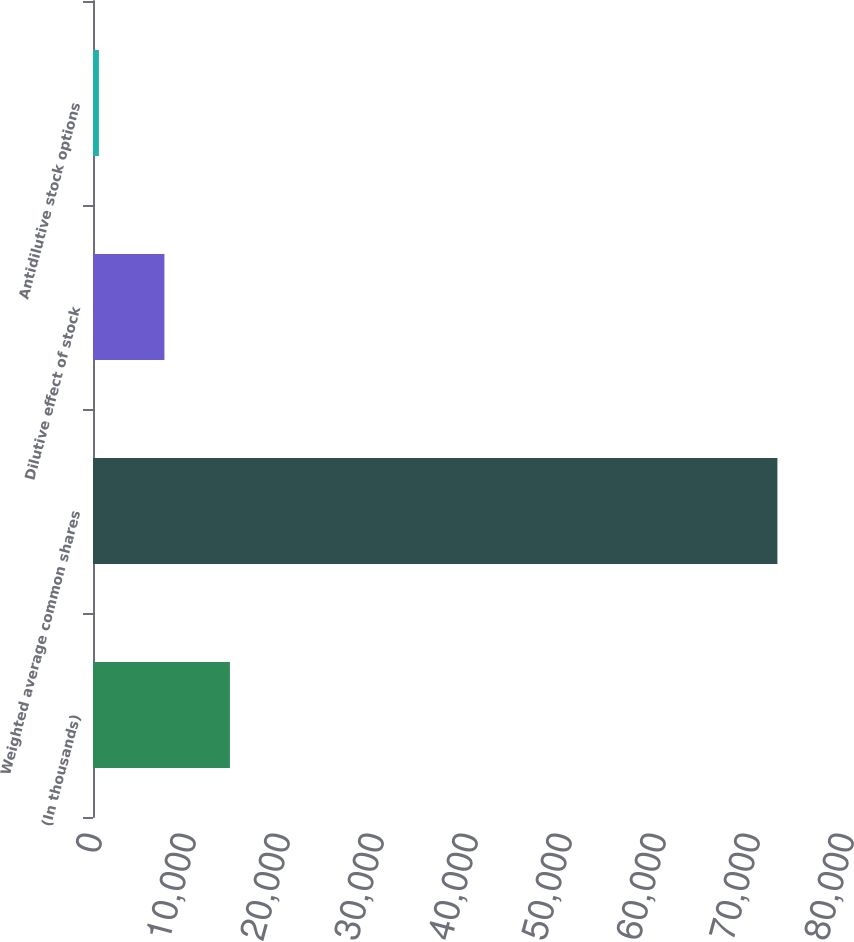Convert chart. <chart><loc_0><loc_0><loc_500><loc_500><bar_chart><fcel>(In thousands)<fcel>Weighted average common shares<fcel>Dilutive effect of stock<fcel>Antidilutive stock options<nl><fcel>14565.6<fcel>72808.3<fcel>7597.3<fcel>629<nl></chart> 